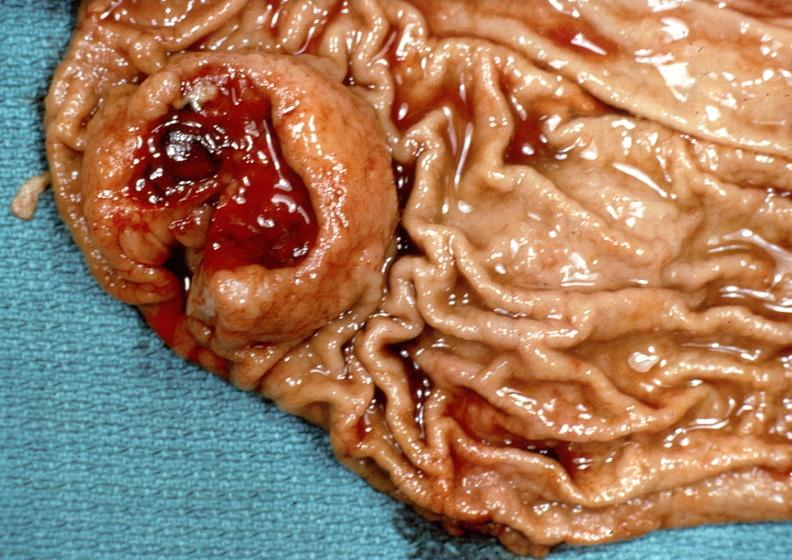where does this belong to?
Answer the question using a single word or phrase. Gastrointestinal system 